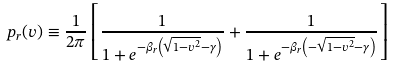Convert formula to latex. <formula><loc_0><loc_0><loc_500><loc_500>p _ { r } ( v ) \equiv \frac { 1 } { 2 \pi } \left [ \frac { 1 } { 1 + e ^ { - \beta _ { r } \left ( \sqrt { 1 - v ^ { 2 } } - \gamma \right ) } } + \frac { 1 } { 1 + e ^ { - \beta _ { r } \left ( - \sqrt { 1 - v ^ { 2 } } - \gamma \right ) } } \right ]</formula> 